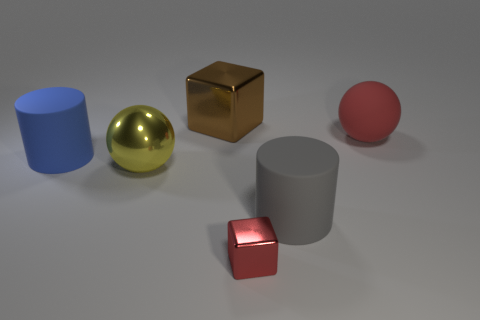Add 4 large red objects. How many objects exist? 10 Subtract all cylinders. How many objects are left? 4 Subtract all rubber things. Subtract all tiny things. How many objects are left? 2 Add 2 large gray matte objects. How many large gray matte objects are left? 3 Add 2 small purple rubber spheres. How many small purple rubber spheres exist? 2 Subtract 0 cyan cylinders. How many objects are left? 6 